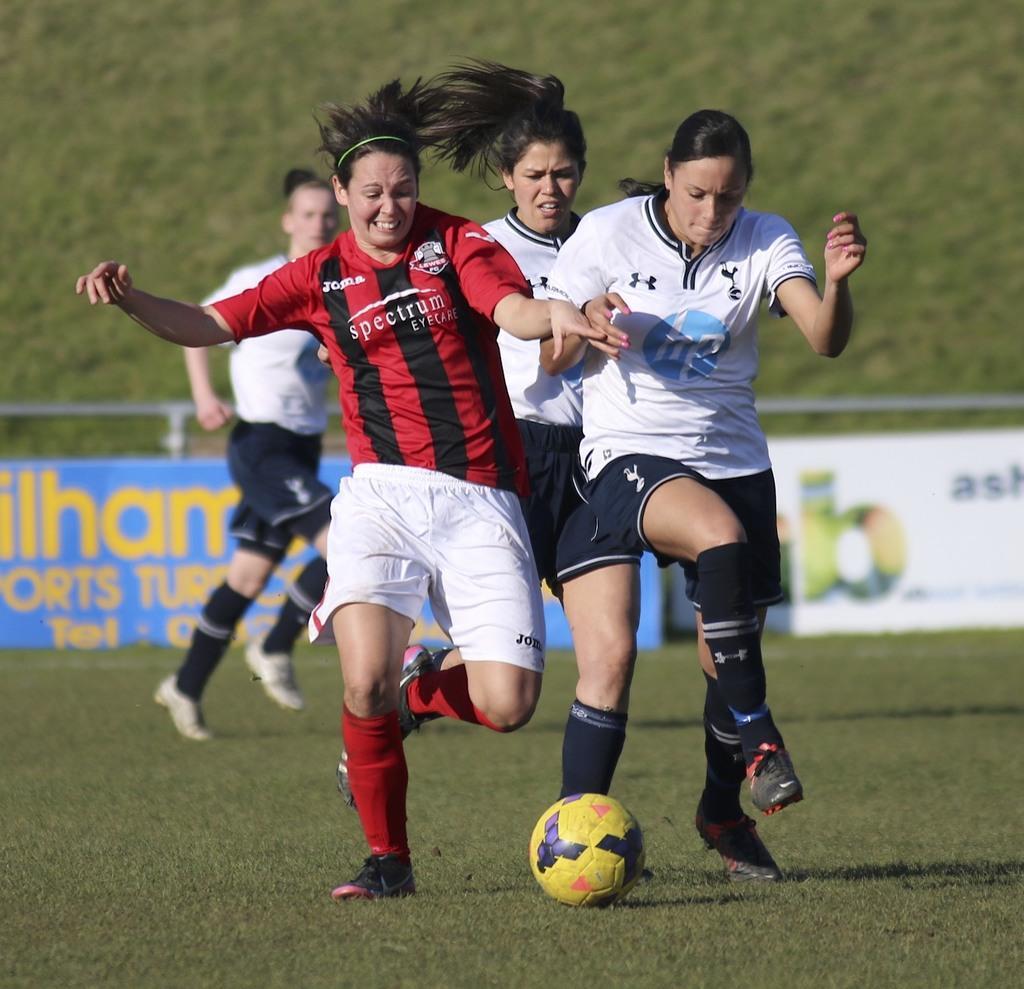Can you describe this image briefly? In this picture we can see group of people, few are playing game in the ground, in front of them we can see a ball, in the background we can find few hoardings and metal rods. 